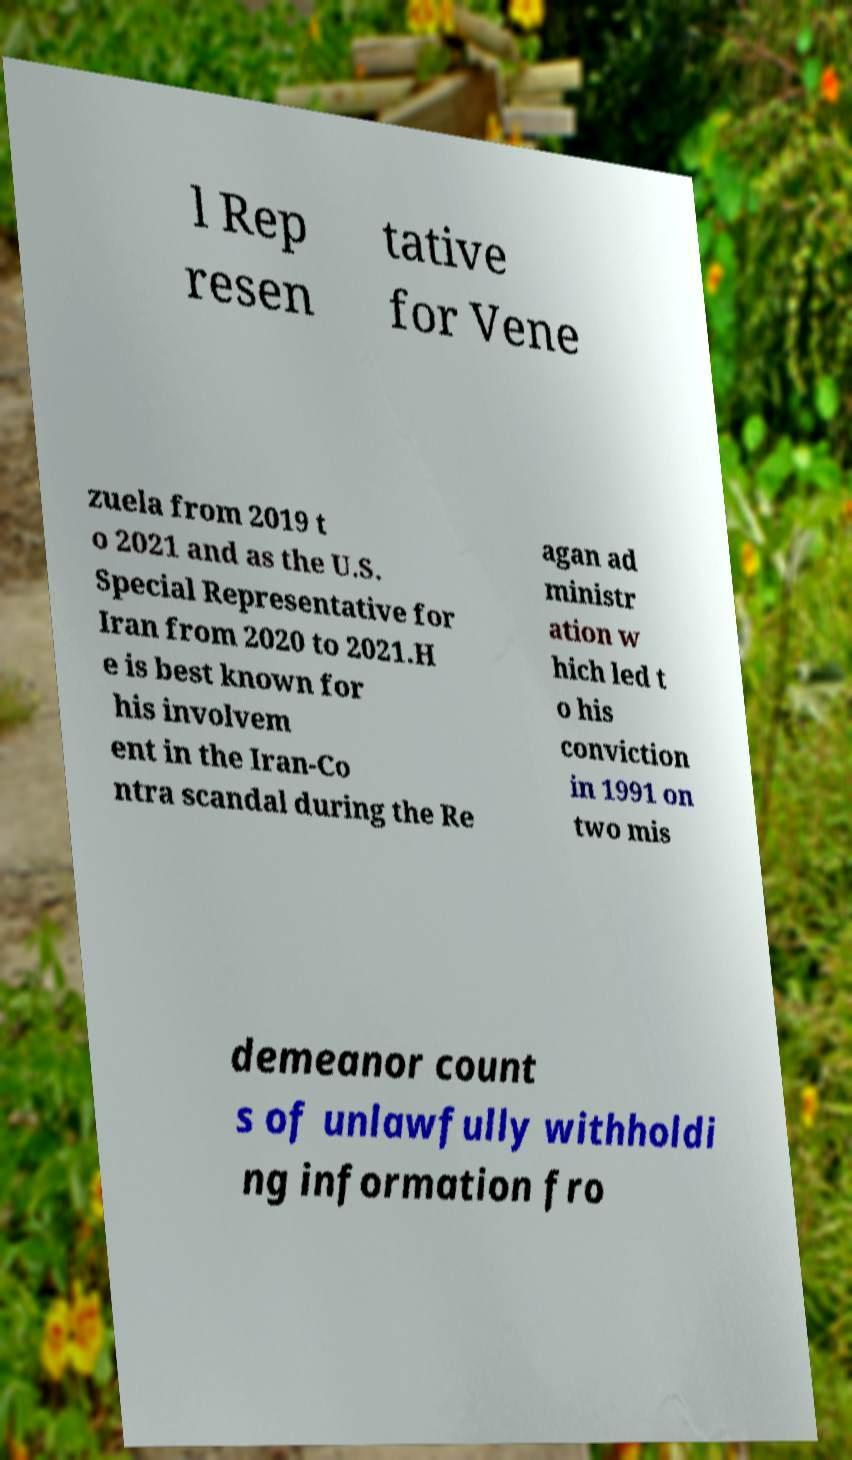Can you accurately transcribe the text from the provided image for me? l Rep resen tative for Vene zuela from 2019 t o 2021 and as the U.S. Special Representative for Iran from 2020 to 2021.H e is best known for his involvem ent in the Iran-Co ntra scandal during the Re agan ad ministr ation w hich led t o his conviction in 1991 on two mis demeanor count s of unlawfully withholdi ng information fro 